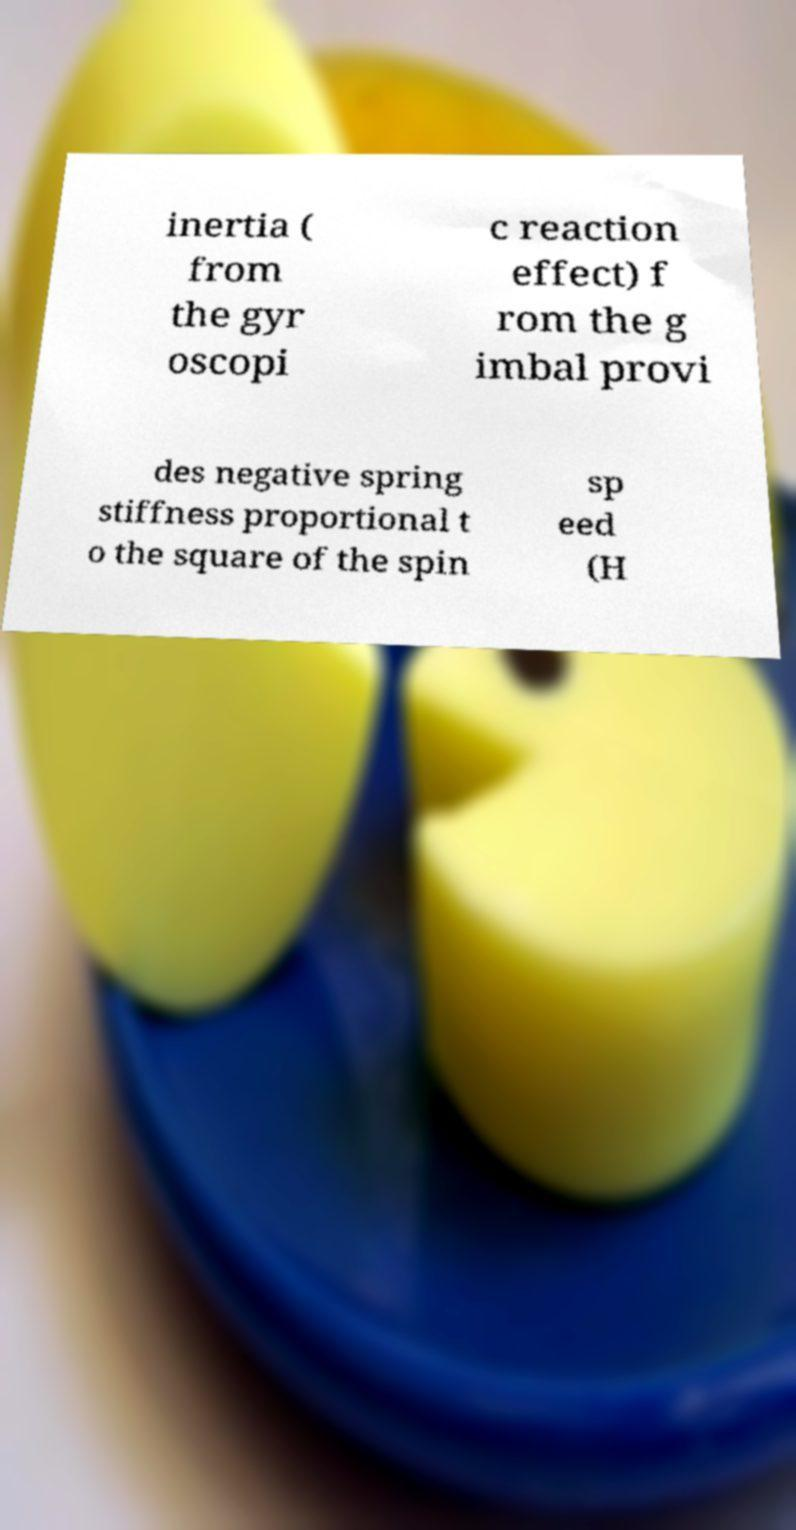Please identify and transcribe the text found in this image. inertia ( from the gyr oscopi c reaction effect) f rom the g imbal provi des negative spring stiffness proportional t o the square of the spin sp eed (H 